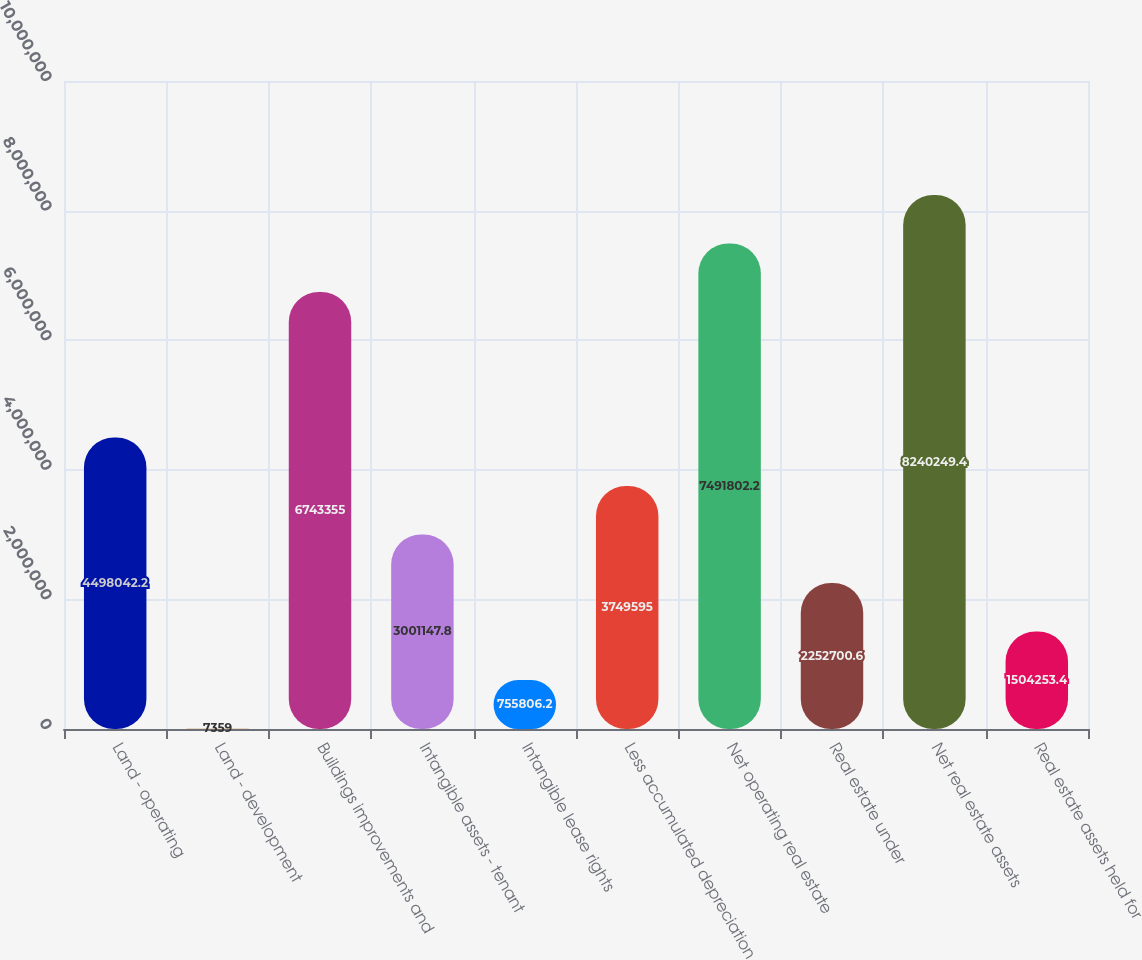<chart> <loc_0><loc_0><loc_500><loc_500><bar_chart><fcel>Land - operating<fcel>Land - development<fcel>Buildings improvements and<fcel>Intangible assets - tenant<fcel>Intangible lease rights<fcel>Less accumulated depreciation<fcel>Net operating real estate<fcel>Real estate under<fcel>Net real estate assets<fcel>Real estate assets held for<nl><fcel>4.49804e+06<fcel>7359<fcel>6.74336e+06<fcel>3.00115e+06<fcel>755806<fcel>3.7496e+06<fcel>7.4918e+06<fcel>2.2527e+06<fcel>8.24025e+06<fcel>1.50425e+06<nl></chart> 